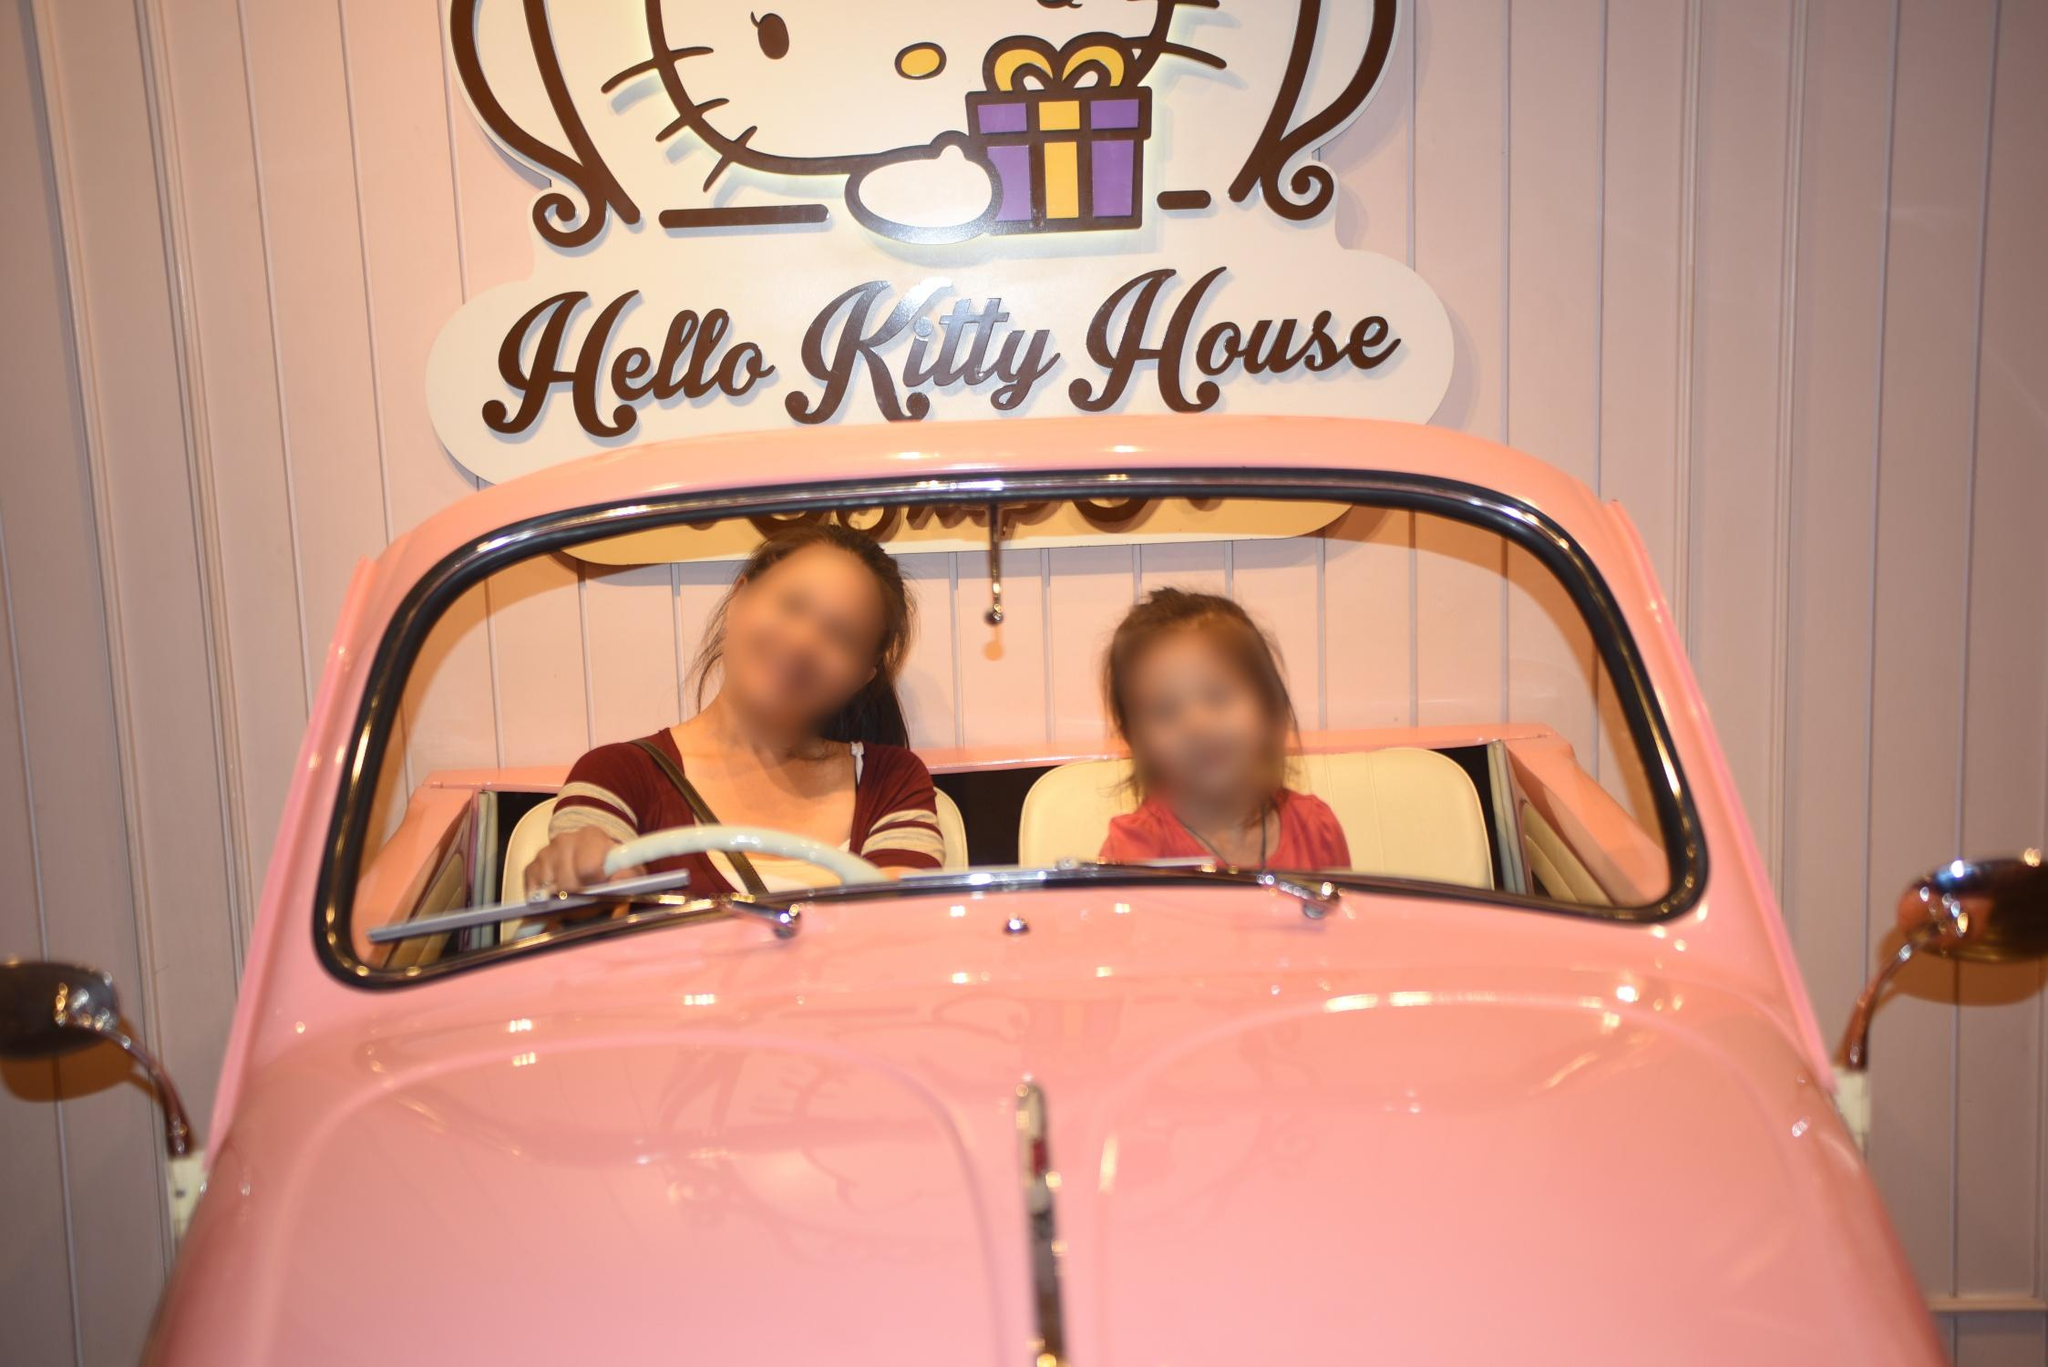What activities can visitors do at places like the 'Hello Kitty House'? Visitors to a 'Hello Kitty House' can enjoy a variety of activities, depending on the venue. They might shop for exclusive Hello Kitty merchandise, dine on creatively themed foods and beverages, take memorable photos with Hello Kitty-inspired surroundings and decor, and participate in interactive events and games that celebrate the iconic character and her world. 